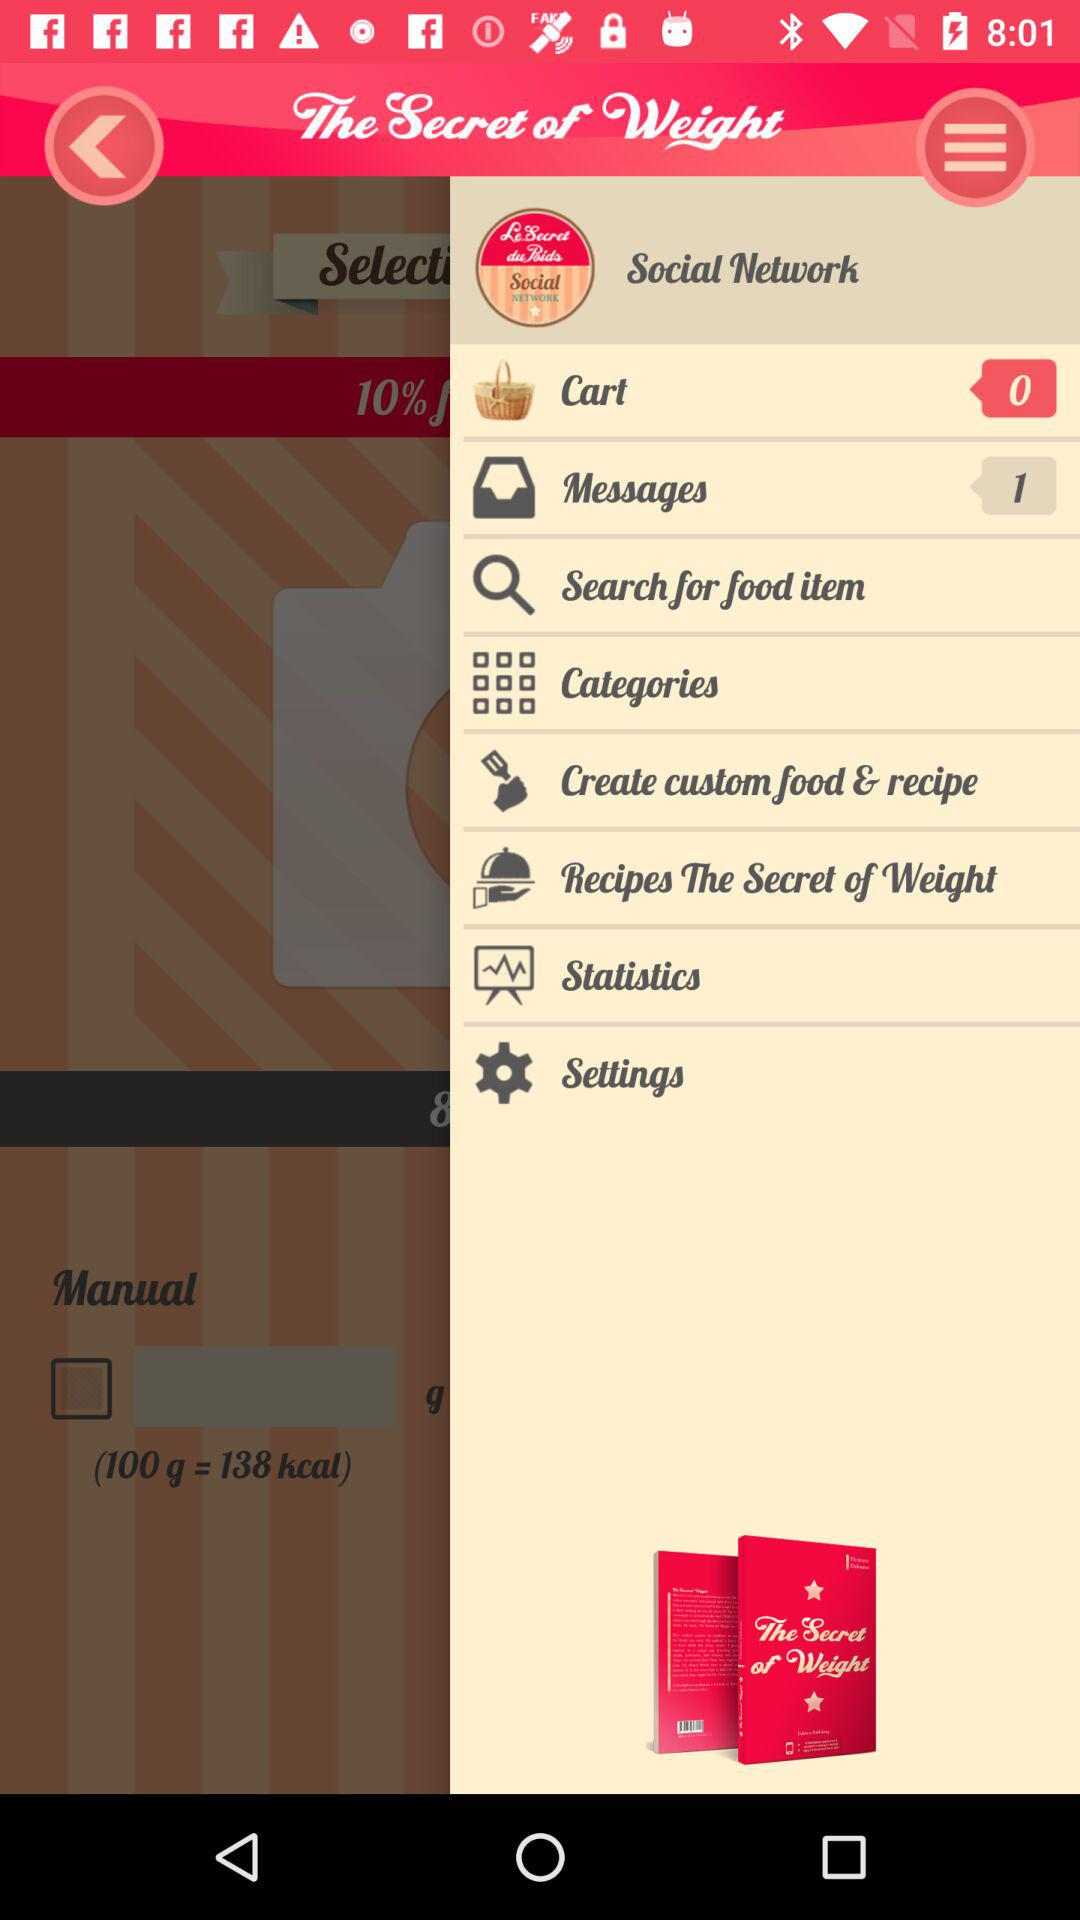Are there any unread messages? There is only 1 unread message. 